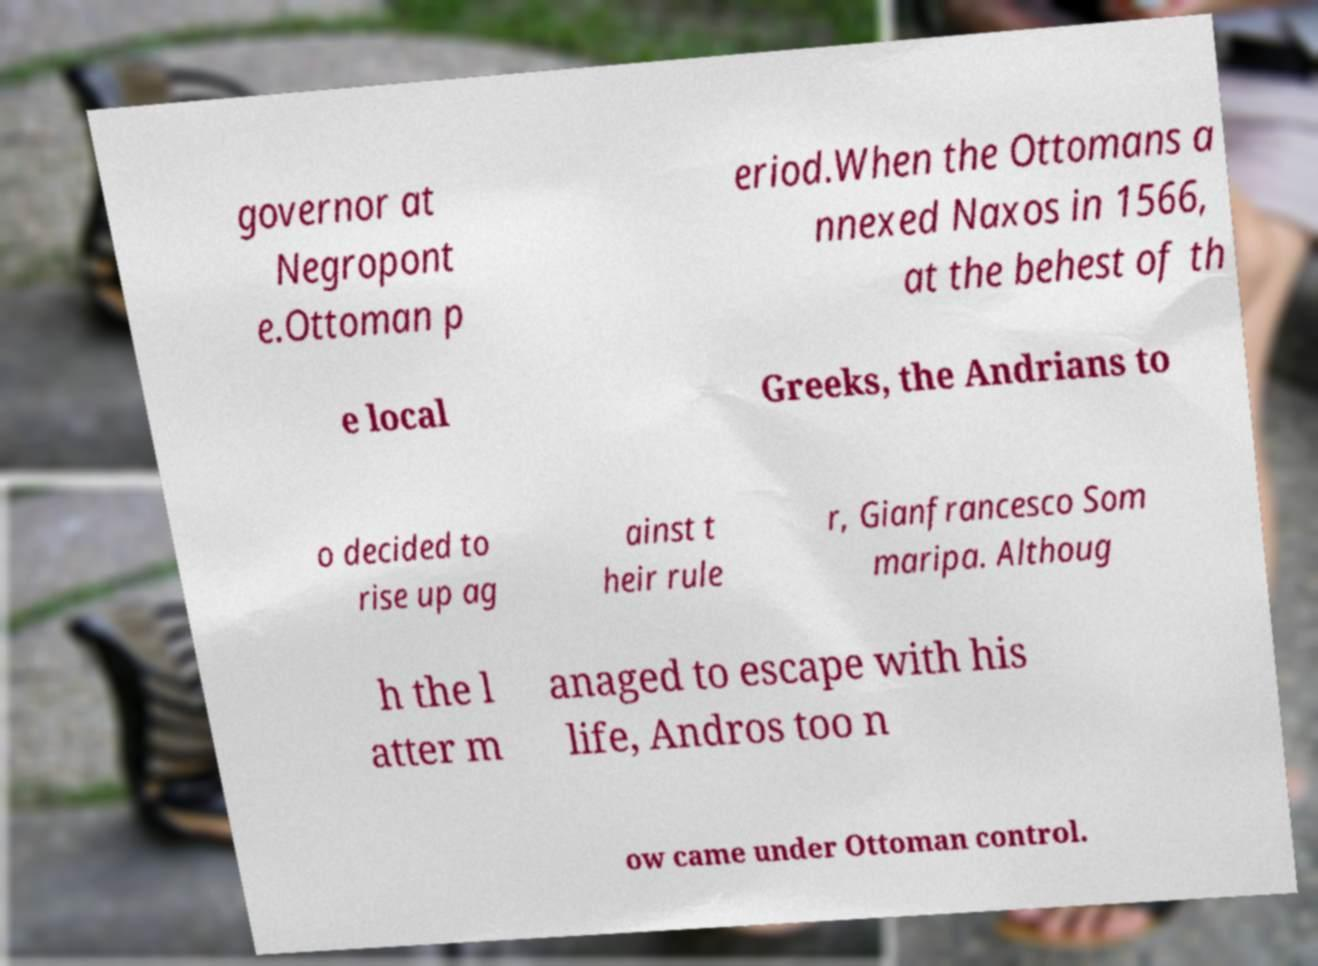Could you assist in decoding the text presented in this image and type it out clearly? governor at Negropont e.Ottoman p eriod.When the Ottomans a nnexed Naxos in 1566, at the behest of th e local Greeks, the Andrians to o decided to rise up ag ainst t heir rule r, Gianfrancesco Som maripa. Althoug h the l atter m anaged to escape with his life, Andros too n ow came under Ottoman control. 